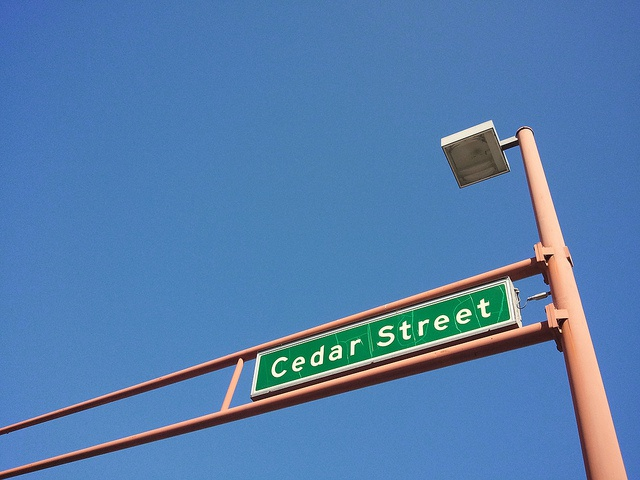Describe the objects in this image and their specific colors. I can see various objects in this image with different colors. 